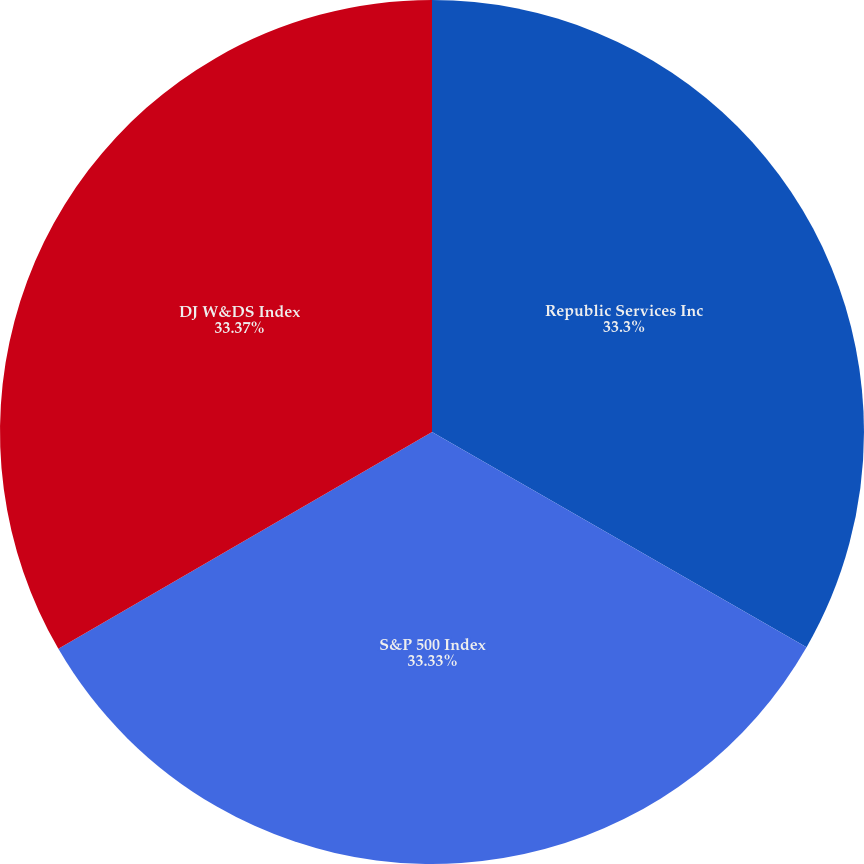Convert chart to OTSL. <chart><loc_0><loc_0><loc_500><loc_500><pie_chart><fcel>Republic Services Inc<fcel>S&P 500 Index<fcel>DJ W&DS Index<nl><fcel>33.3%<fcel>33.33%<fcel>33.37%<nl></chart> 